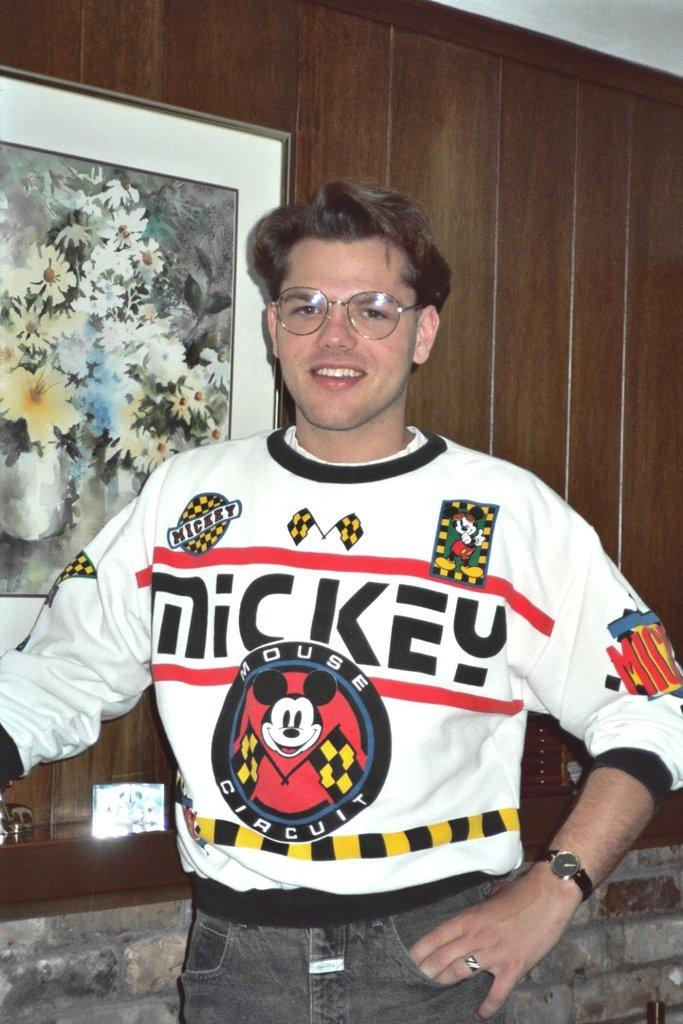<image>
Summarize the visual content of the image. Man wearing a sweater that says Mickey on it. 